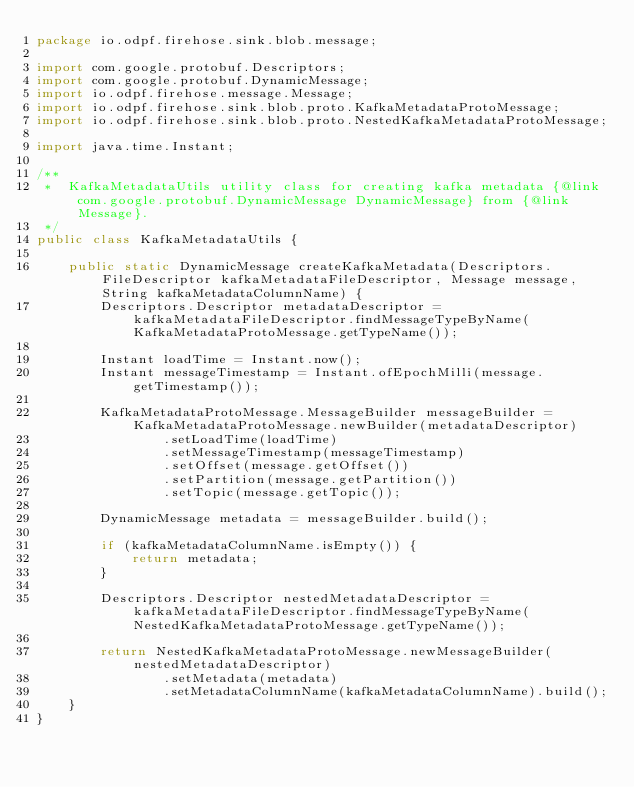<code> <loc_0><loc_0><loc_500><loc_500><_Java_>package io.odpf.firehose.sink.blob.message;

import com.google.protobuf.Descriptors;
import com.google.protobuf.DynamicMessage;
import io.odpf.firehose.message.Message;
import io.odpf.firehose.sink.blob.proto.KafkaMetadataProtoMessage;
import io.odpf.firehose.sink.blob.proto.NestedKafkaMetadataProtoMessage;

import java.time.Instant;

/**
 *  KafkaMetadataUtils utility class for creating kafka metadata {@link com.google.protobuf.DynamicMessage DynamicMessage} from {@link Message}.
 */
public class KafkaMetadataUtils {

    public static DynamicMessage createKafkaMetadata(Descriptors.FileDescriptor kafkaMetadataFileDescriptor, Message message, String kafkaMetadataColumnName) {
        Descriptors.Descriptor metadataDescriptor = kafkaMetadataFileDescriptor.findMessageTypeByName(KafkaMetadataProtoMessage.getTypeName());

        Instant loadTime = Instant.now();
        Instant messageTimestamp = Instant.ofEpochMilli(message.getTimestamp());

        KafkaMetadataProtoMessage.MessageBuilder messageBuilder = KafkaMetadataProtoMessage.newBuilder(metadataDescriptor)
                .setLoadTime(loadTime)
                .setMessageTimestamp(messageTimestamp)
                .setOffset(message.getOffset())
                .setPartition(message.getPartition())
                .setTopic(message.getTopic());

        DynamicMessage metadata = messageBuilder.build();

        if (kafkaMetadataColumnName.isEmpty()) {
            return metadata;
        }

        Descriptors.Descriptor nestedMetadataDescriptor = kafkaMetadataFileDescriptor.findMessageTypeByName(NestedKafkaMetadataProtoMessage.getTypeName());

        return NestedKafkaMetadataProtoMessage.newMessageBuilder(nestedMetadataDescriptor)
                .setMetadata(metadata)
                .setMetadataColumnName(kafkaMetadataColumnName).build();
    }
}
</code> 